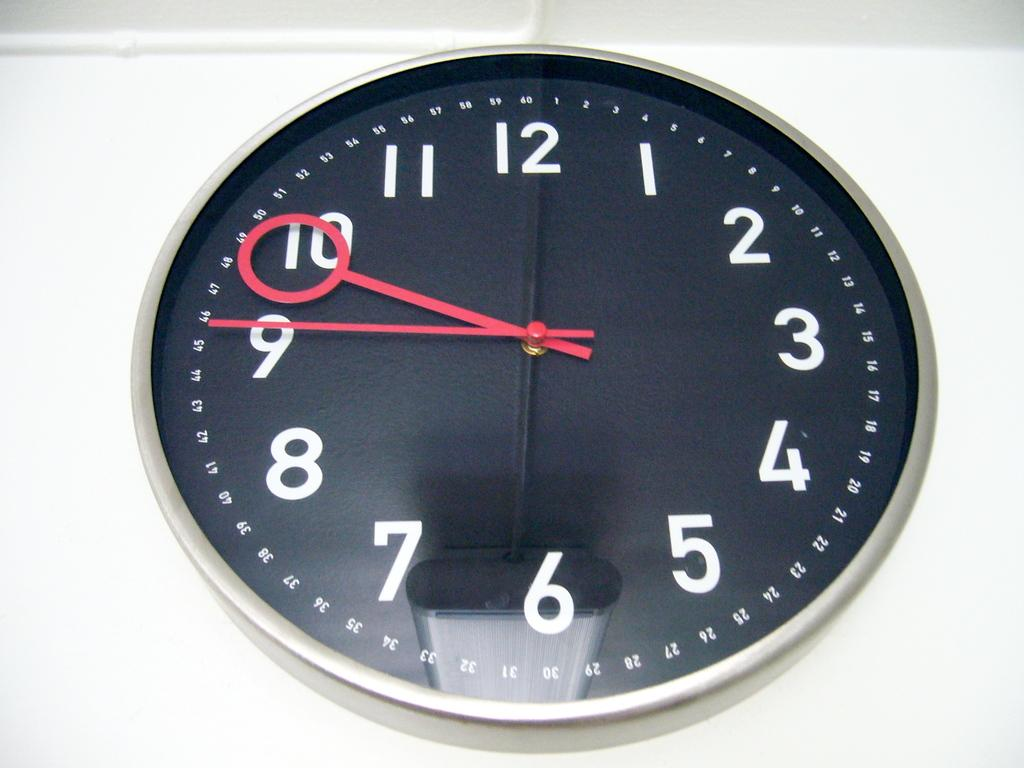<image>
Present a compact description of the photo's key features. A black clock with red hands shows that the time is 9:45. 